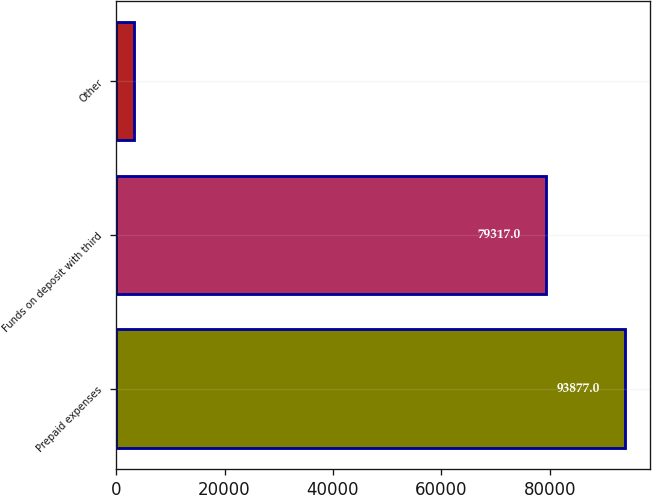Convert chart to OTSL. <chart><loc_0><loc_0><loc_500><loc_500><bar_chart><fcel>Prepaid expenses<fcel>Funds on deposit with third<fcel>Other<nl><fcel>93877<fcel>79317<fcel>3220<nl></chart> 